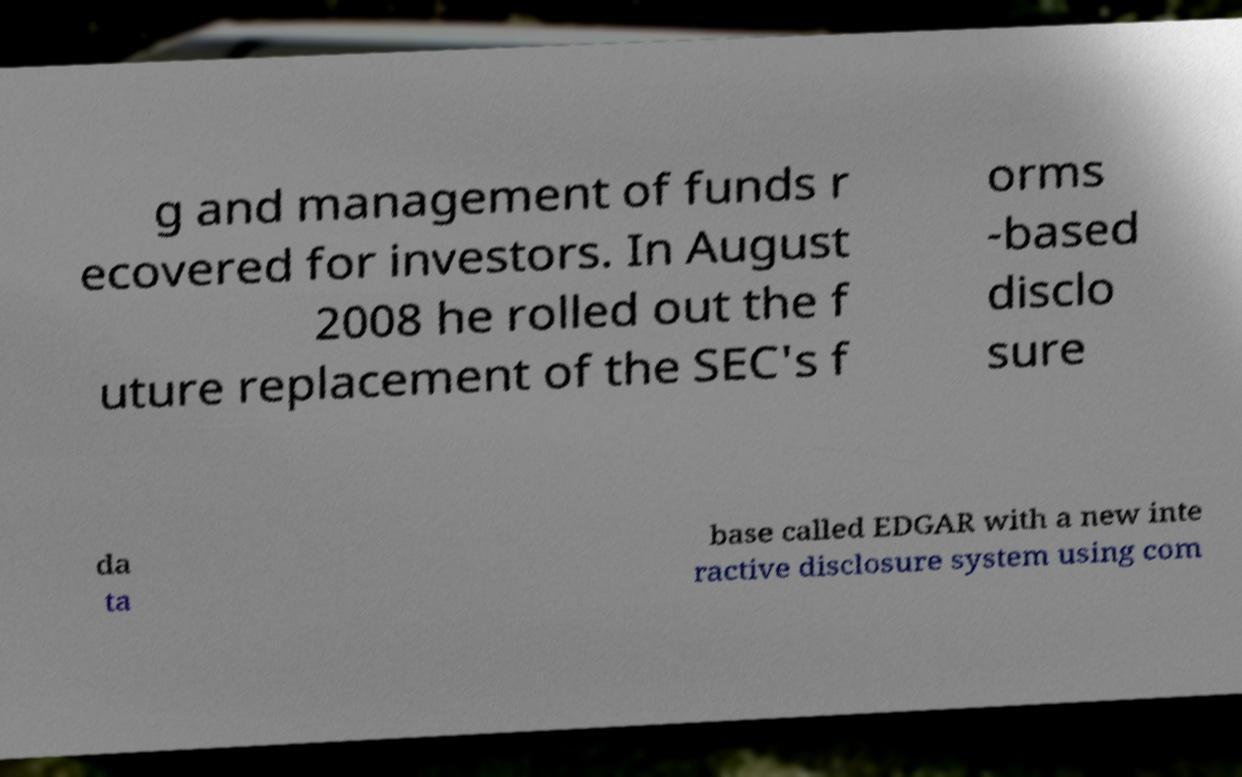Please read and relay the text visible in this image. What does it say? g and management of funds r ecovered for investors. In August 2008 he rolled out the f uture replacement of the SEC's f orms -based disclo sure da ta base called EDGAR with a new inte ractive disclosure system using com 